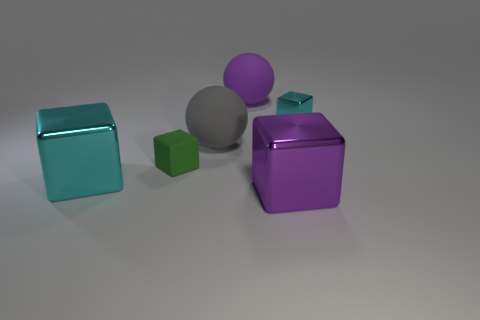There is a large metal thing that is the same color as the small shiny cube; what shape is it?
Make the answer very short. Cube. Are there any other blocks of the same color as the small metal cube?
Provide a succinct answer. Yes. Is there anything else that has the same color as the small metal thing?
Keep it short and to the point. Yes. Is the number of purple rubber things to the left of the tiny metal thing greater than the number of red metallic things?
Keep it short and to the point. Yes. There is a purple object in front of the small cyan shiny cube; is it the same shape as the tiny cyan metal thing?
Provide a short and direct response. Yes. How many things are brown matte balls or cubes that are right of the big cyan metal thing?
Provide a succinct answer. 3. There is a object that is right of the big purple matte ball and behind the tiny matte cube; how big is it?
Give a very brief answer. Small. Is the number of large things that are on the right side of the small green block greater than the number of large gray objects that are on the right side of the small shiny object?
Offer a terse response. Yes. There is a gray matte thing; is it the same shape as the large purple thing that is behind the tiny green object?
Provide a short and direct response. Yes. What number of other things are the same shape as the big purple rubber object?
Offer a terse response. 1. 